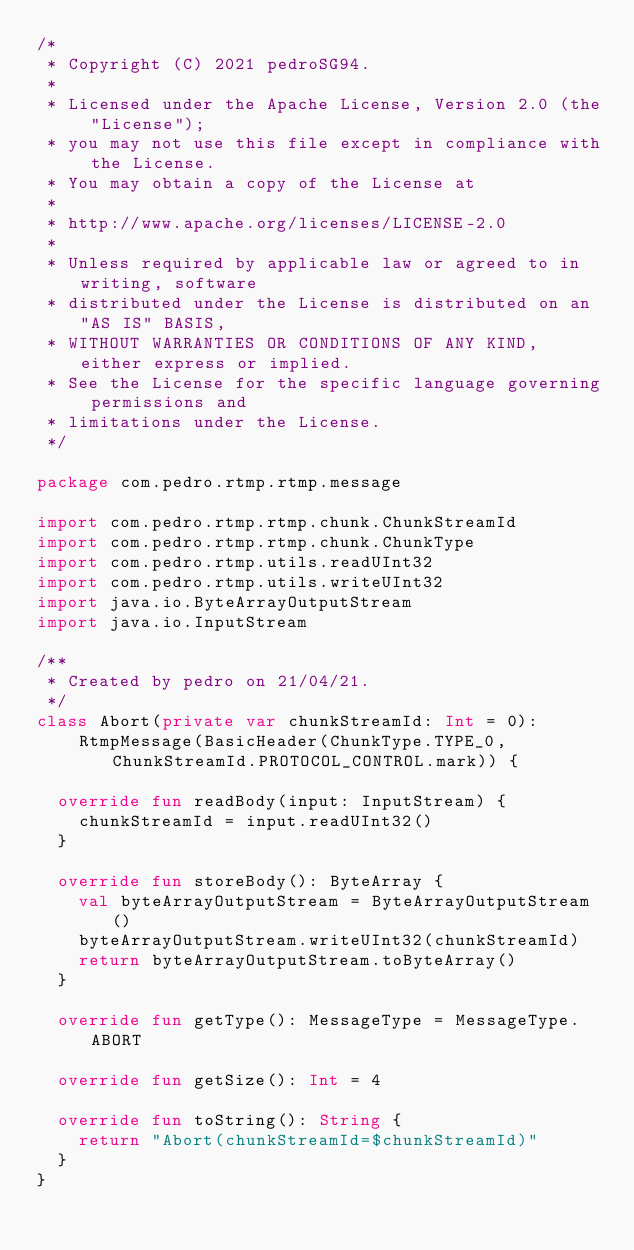<code> <loc_0><loc_0><loc_500><loc_500><_Kotlin_>/*
 * Copyright (C) 2021 pedroSG94.
 *
 * Licensed under the Apache License, Version 2.0 (the "License");
 * you may not use this file except in compliance with the License.
 * You may obtain a copy of the License at
 *
 * http://www.apache.org/licenses/LICENSE-2.0
 *
 * Unless required by applicable law or agreed to in writing, software
 * distributed under the License is distributed on an "AS IS" BASIS,
 * WITHOUT WARRANTIES OR CONDITIONS OF ANY KIND, either express or implied.
 * See the License for the specific language governing permissions and
 * limitations under the License.
 */

package com.pedro.rtmp.rtmp.message

import com.pedro.rtmp.rtmp.chunk.ChunkStreamId
import com.pedro.rtmp.rtmp.chunk.ChunkType
import com.pedro.rtmp.utils.readUInt32
import com.pedro.rtmp.utils.writeUInt32
import java.io.ByteArrayOutputStream
import java.io.InputStream

/**
 * Created by pedro on 21/04/21.
 */
class Abort(private var chunkStreamId: Int = 0):
    RtmpMessage(BasicHeader(ChunkType.TYPE_0, ChunkStreamId.PROTOCOL_CONTROL.mark)) {

  override fun readBody(input: InputStream) {
    chunkStreamId = input.readUInt32()
  }

  override fun storeBody(): ByteArray {
    val byteArrayOutputStream = ByteArrayOutputStream()
    byteArrayOutputStream.writeUInt32(chunkStreamId)
    return byteArrayOutputStream.toByteArray()
  }

  override fun getType(): MessageType = MessageType.ABORT

  override fun getSize(): Int = 4

  override fun toString(): String {
    return "Abort(chunkStreamId=$chunkStreamId)"
  }
}</code> 